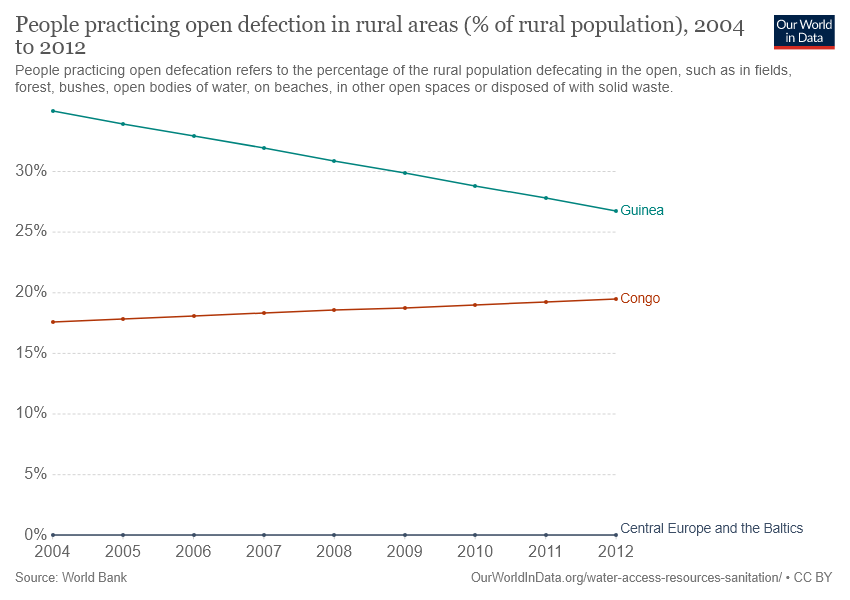Highlight a few significant elements in this photo. In 2008, the median value for Guinea was reported. The rural population in Congo was highest in the year 2004, at 0.15%. 